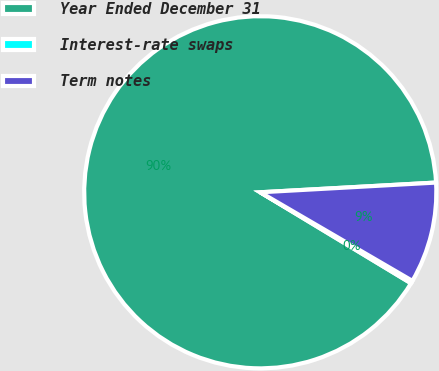Convert chart. <chart><loc_0><loc_0><loc_500><loc_500><pie_chart><fcel>Year Ended December 31<fcel>Interest-rate swaps<fcel>Term notes<nl><fcel>90.48%<fcel>0.25%<fcel>9.27%<nl></chart> 